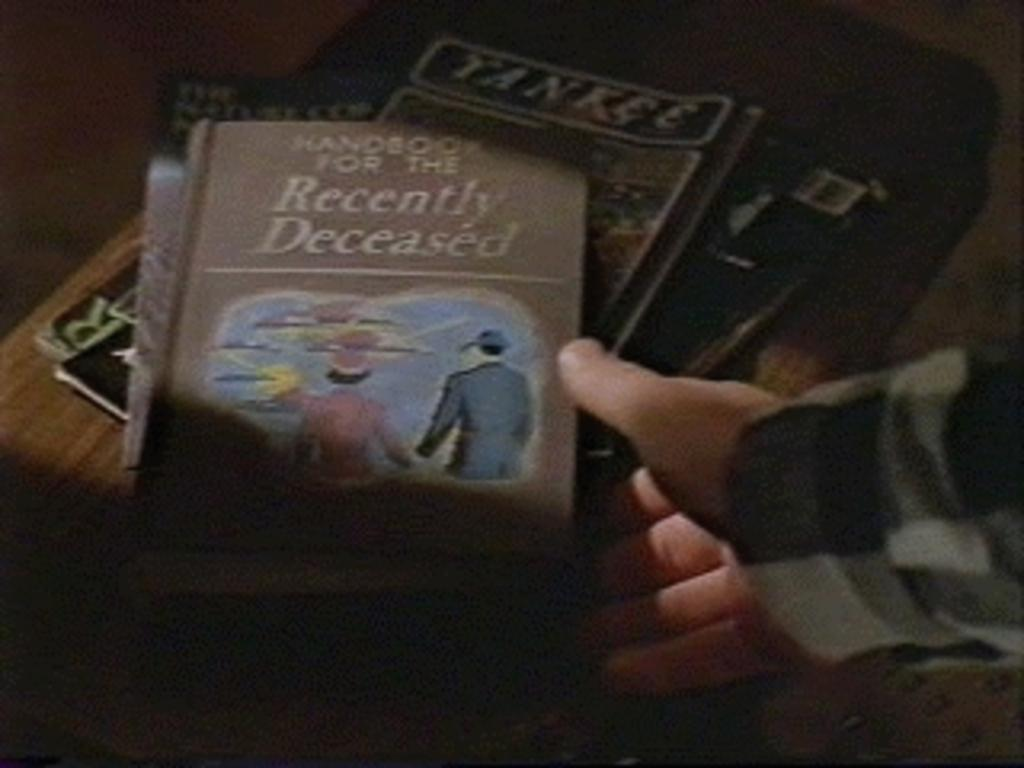What objects are on the table in the image? There are books on a table in the image. Can you describe any other elements in the image? A person's hand is visible in the image. What type of fowl can be seen in the aftermath of the image? There is no fowl or aftermath present in the image; it only features books on a table and a person's hand. 